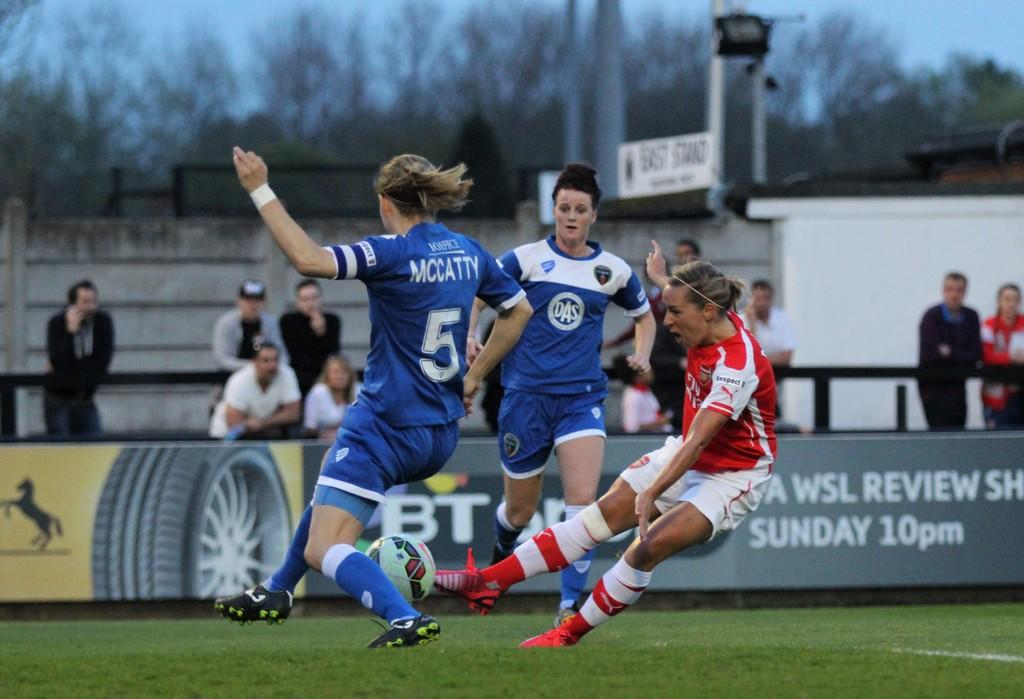<image>
Relay a brief, clear account of the picture shown. The player facing away from the camera is number 5 